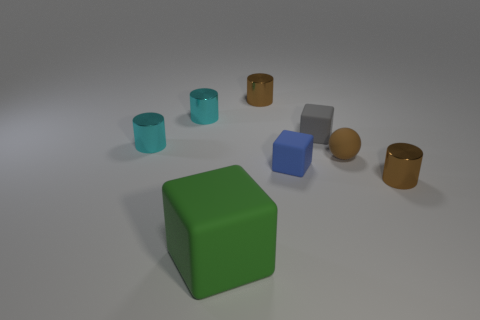What is the color of the rubber thing on the left side of the tiny brown shiny thing left of the small brown rubber object? green 